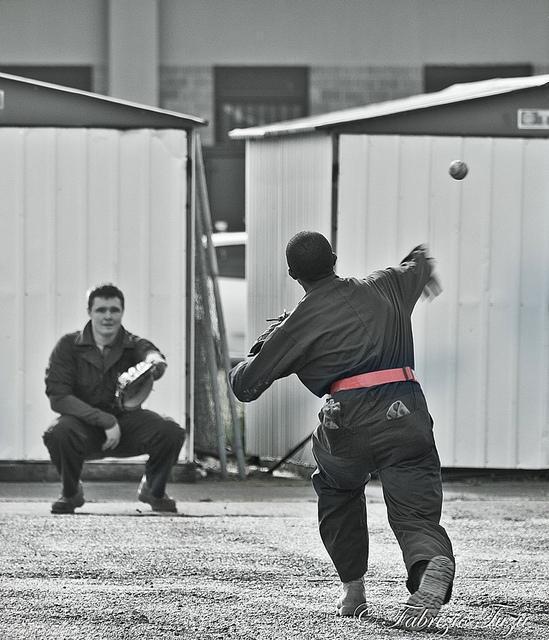How many people are there?
Give a very brief answer. 2. How many people are driving a motorcycle in this image?
Give a very brief answer. 0. 